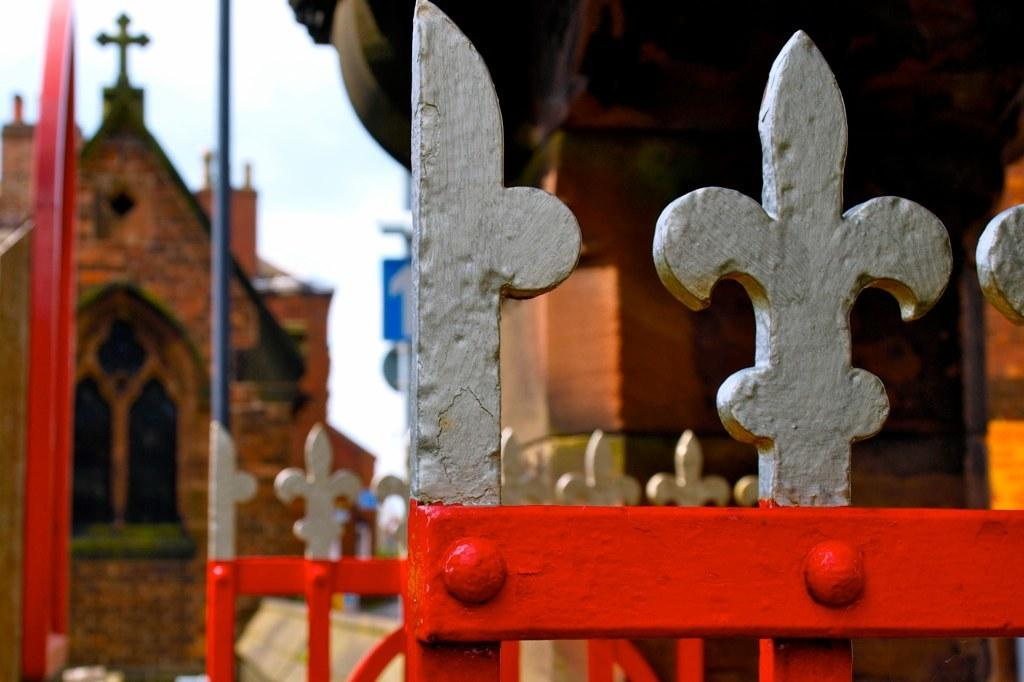What structures are present in the image? There are gates in the image. What can be seen in the distance behind the gates? There are buildings in the background of the image. What part of the natural environment is visible in the image? The sky is visible in the image. How would you describe the clarity of the background in the image? The background appears blurry. What type of list can be seen hanging on the gates in the image? There is no list present in the image; it only features gates and a blurry background. 